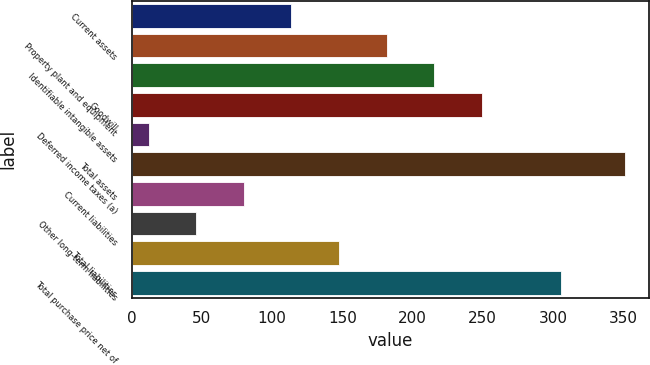Convert chart to OTSL. <chart><loc_0><loc_0><loc_500><loc_500><bar_chart><fcel>Current assets<fcel>Property plant and equipment<fcel>Identifiable intangible assets<fcel>Goodwill<fcel>Deferred income taxes (a)<fcel>Total assets<fcel>Current liabilities<fcel>Other long-term liabilities<fcel>Total liabilities<fcel>Total purchase price net of<nl><fcel>113.7<fcel>181.5<fcel>215.4<fcel>249.3<fcel>12<fcel>351<fcel>79.8<fcel>45.9<fcel>147.6<fcel>306<nl></chart> 